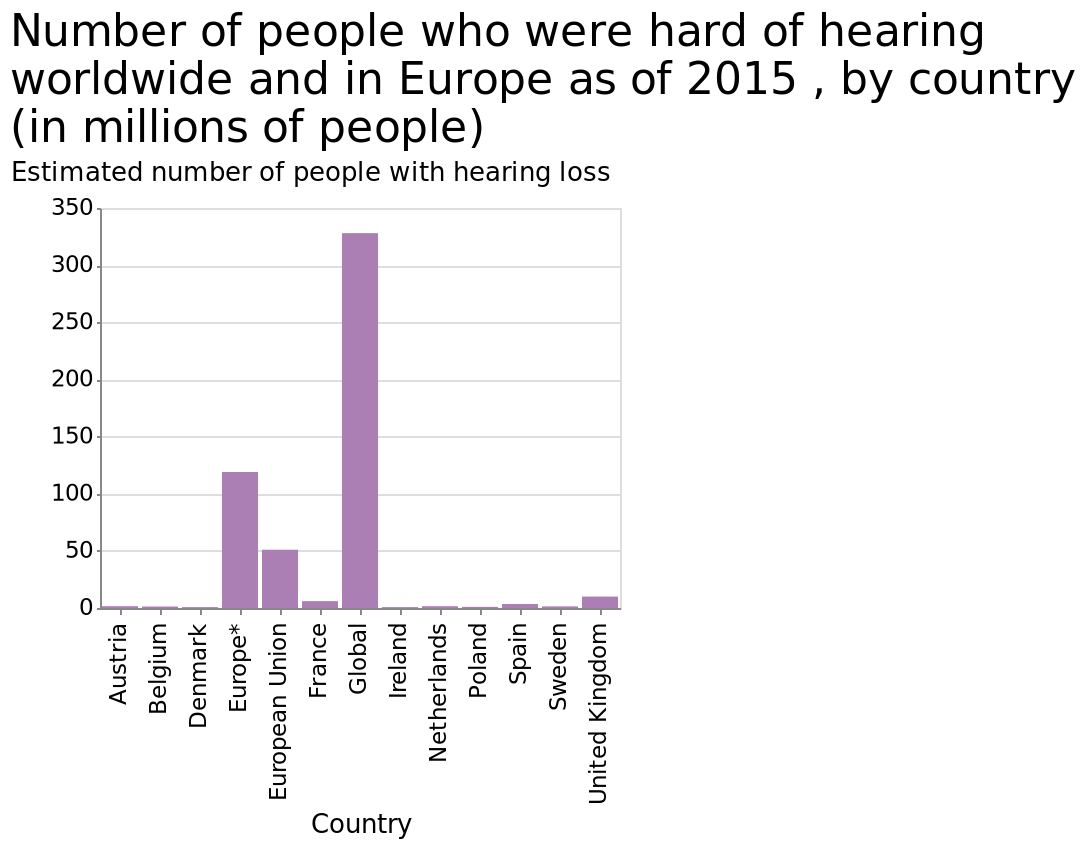<image>
please enumerates aspects of the construction of the chart Number of people who were hard of hearing worldwide and in Europe as of 2015 , by country (in millions of people) is a bar plot. Estimated number of people with hearing loss is measured along the y-axis. A categorical scale from Austria to United Kingdom can be seen along the x-axis, labeled Country. What does the x-axis represent in the bar plot? The x-axis in the bar plot represents different countries, ranging from Austria to the United Kingdom. Is the estimated number of people with hearing loss measured along the x-axis? No.Number of people who were hard of hearing worldwide and in Europe as of 2015 , by country (in millions of people) is a bar plot. Estimated number of people with hearing loss is measured along the y-axis. A categorical scale from Austria to United Kingdom can be seen along the x-axis, labeled Country. 